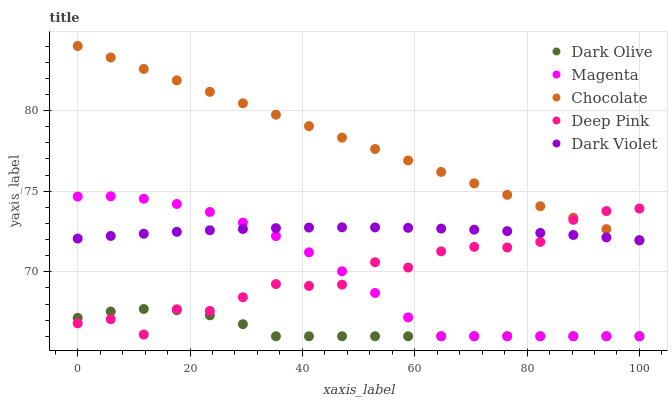Does Dark Olive have the minimum area under the curve?
Answer yes or no. Yes. Does Chocolate have the maximum area under the curve?
Answer yes or no. Yes. Does Dark Violet have the minimum area under the curve?
Answer yes or no. No. Does Dark Violet have the maximum area under the curve?
Answer yes or no. No. Is Chocolate the smoothest?
Answer yes or no. Yes. Is Deep Pink the roughest?
Answer yes or no. Yes. Is Dark Olive the smoothest?
Answer yes or no. No. Is Dark Olive the roughest?
Answer yes or no. No. Does Magenta have the lowest value?
Answer yes or no. Yes. Does Dark Violet have the lowest value?
Answer yes or no. No. Does Chocolate have the highest value?
Answer yes or no. Yes. Does Dark Violet have the highest value?
Answer yes or no. No. Is Dark Olive less than Dark Violet?
Answer yes or no. Yes. Is Dark Violet greater than Dark Olive?
Answer yes or no. Yes. Does Deep Pink intersect Dark Olive?
Answer yes or no. Yes. Is Deep Pink less than Dark Olive?
Answer yes or no. No. Is Deep Pink greater than Dark Olive?
Answer yes or no. No. Does Dark Olive intersect Dark Violet?
Answer yes or no. No. 